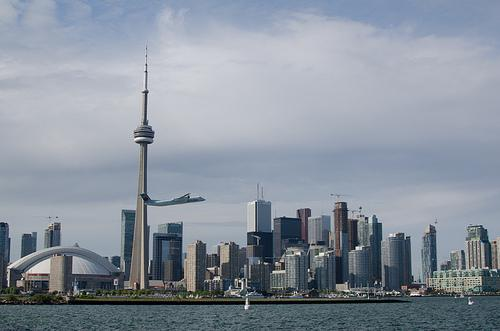Question: where was this photo taken?
Choices:
A. On an urban waterfront.
B. In a boat.
C. By the ship.
D. In the water.
Answer with the letter. Answer: A Question: what is present?
Choices:
A. Buildings.
B. Trees.
C. Ferns.
D. Venus fly traps.
Answer with the letter. Answer: A Question: what else is visible?
Choices:
A. Water.
B. Cookies.
C. Flowers.
D. Cake.
Answer with the letter. Answer: A Question: who is present?
Choices:
A. Nobody.
B. Dogs.
C. Horses.
D. A farmer.
Answer with the letter. Answer: A 